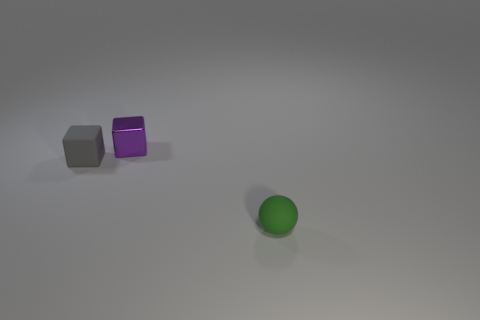What is the shape of the gray thing that is made of the same material as the green sphere?
Your answer should be compact. Cube. Are there any other things that have the same color as the tiny sphere?
Your response must be concise. No. Are there fewer cubes that are right of the tiny green sphere than small blocks?
Provide a short and direct response. Yes. What is the cube that is in front of the purple block made of?
Give a very brief answer. Rubber. The matte thing left of the rubber thing that is on the right side of the tiny rubber object behind the small green ball is what shape?
Ensure brevity in your answer.  Cube. Are there fewer tiny green balls than tiny cyan cylinders?
Offer a terse response. No. There is a tiny sphere; are there any purple cubes on the right side of it?
Give a very brief answer. No. There is a object that is in front of the purple thing and on the right side of the gray matte thing; what is its shape?
Provide a succinct answer. Sphere. Is there another tiny thing that has the same shape as the gray thing?
Your answer should be very brief. Yes. Are there more tiny things than brown objects?
Keep it short and to the point. Yes. 